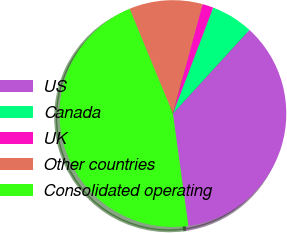<chart> <loc_0><loc_0><loc_500><loc_500><pie_chart><fcel>US<fcel>Canada<fcel>UK<fcel>Other countries<fcel>Consolidated operating<nl><fcel>36.04%<fcel>6.01%<fcel>1.57%<fcel>10.44%<fcel>45.95%<nl></chart> 